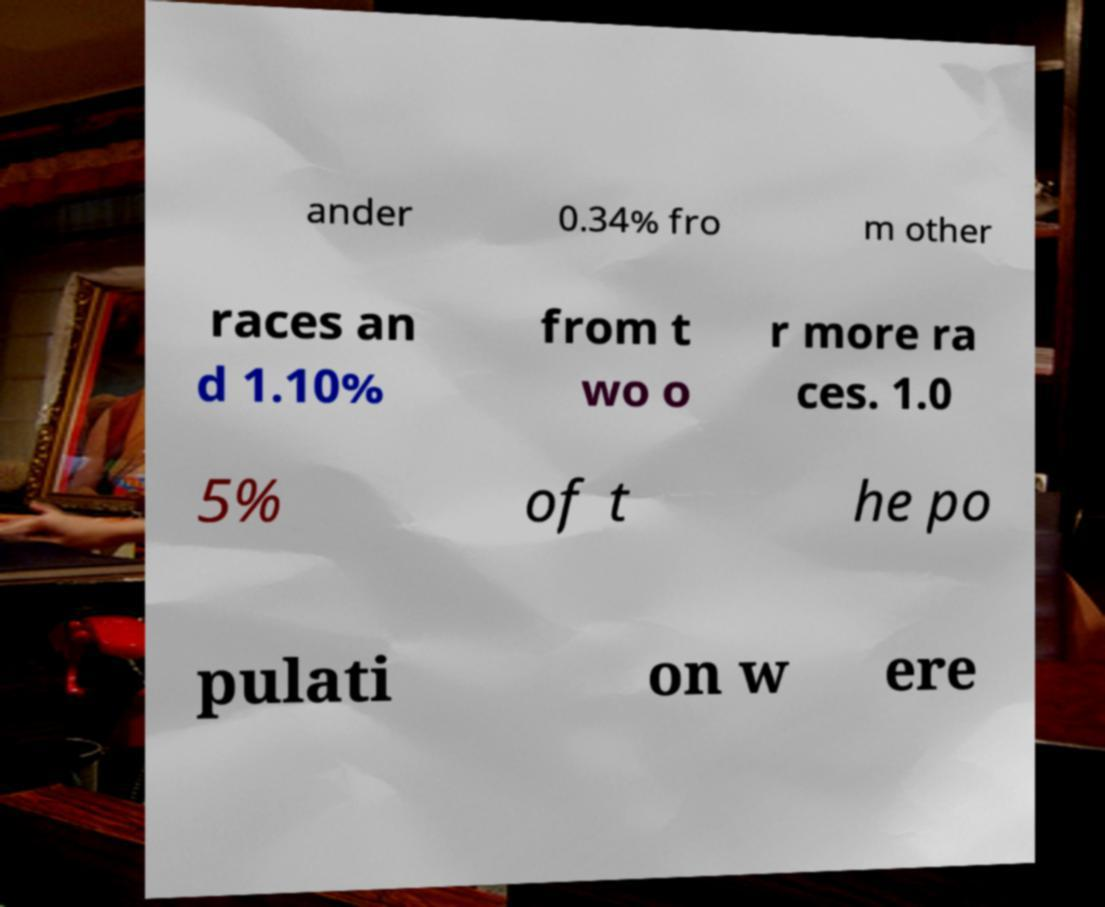Could you extract and type out the text from this image? ander 0.34% fro m other races an d 1.10% from t wo o r more ra ces. 1.0 5% of t he po pulati on w ere 